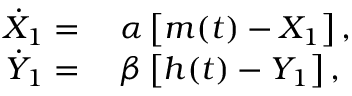<formula> <loc_0><loc_0><loc_500><loc_500>\begin{array} { r l } { \dot { X } _ { 1 } } & \alpha \left [ m ( t ) - X _ { 1 } \right ] , } \\ { \dot { Y } _ { 1 } } & \beta \left [ h ( t ) - Y _ { 1 } \right ] , } \end{array}</formula> 